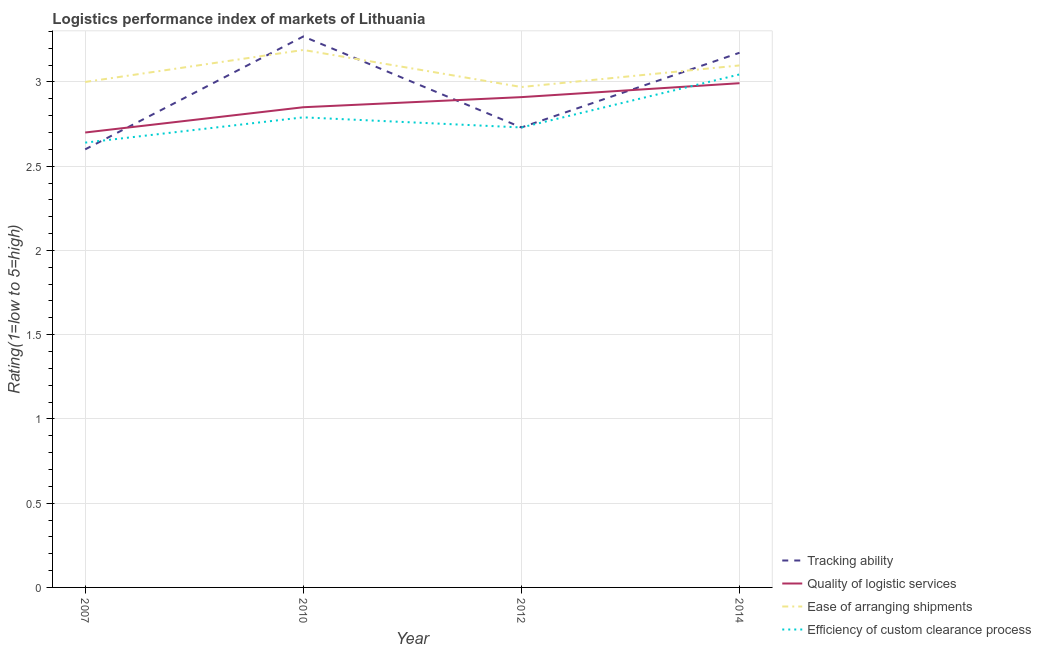What is the lpi rating of tracking ability in 2010?
Offer a very short reply. 3.27. Across all years, what is the maximum lpi rating of quality of logistic services?
Make the answer very short. 2.99. Across all years, what is the minimum lpi rating of ease of arranging shipments?
Provide a short and direct response. 2.97. In which year was the lpi rating of ease of arranging shipments maximum?
Make the answer very short. 2010. In which year was the lpi rating of efficiency of custom clearance process minimum?
Provide a short and direct response. 2007. What is the total lpi rating of efficiency of custom clearance process in the graph?
Your answer should be compact. 11.2. What is the difference between the lpi rating of ease of arranging shipments in 2012 and that in 2014?
Give a very brief answer. -0.13. What is the difference between the lpi rating of tracking ability in 2012 and the lpi rating of quality of logistic services in 2010?
Give a very brief answer. -0.12. What is the average lpi rating of efficiency of custom clearance process per year?
Keep it short and to the point. 2.8. In the year 2010, what is the difference between the lpi rating of quality of logistic services and lpi rating of tracking ability?
Offer a terse response. -0.42. In how many years, is the lpi rating of ease of arranging shipments greater than 1.5?
Your answer should be very brief. 4. What is the ratio of the lpi rating of efficiency of custom clearance process in 2007 to that in 2010?
Offer a very short reply. 0.95. What is the difference between the highest and the second highest lpi rating of efficiency of custom clearance process?
Your answer should be compact. 0.25. What is the difference between the highest and the lowest lpi rating of ease of arranging shipments?
Make the answer very short. 0.22. Is the sum of the lpi rating of ease of arranging shipments in 2007 and 2012 greater than the maximum lpi rating of tracking ability across all years?
Provide a succinct answer. Yes. What is the difference between two consecutive major ticks on the Y-axis?
Provide a succinct answer. 0.5. Does the graph contain any zero values?
Give a very brief answer. No. How many legend labels are there?
Provide a succinct answer. 4. What is the title of the graph?
Your response must be concise. Logistics performance index of markets of Lithuania. What is the label or title of the Y-axis?
Your answer should be very brief. Rating(1=low to 5=high). What is the Rating(1=low to 5=high) in Tracking ability in 2007?
Give a very brief answer. 2.6. What is the Rating(1=low to 5=high) of Quality of logistic services in 2007?
Provide a succinct answer. 2.7. What is the Rating(1=low to 5=high) of Ease of arranging shipments in 2007?
Offer a very short reply. 3. What is the Rating(1=low to 5=high) in Efficiency of custom clearance process in 2007?
Keep it short and to the point. 2.64. What is the Rating(1=low to 5=high) of Tracking ability in 2010?
Offer a terse response. 3.27. What is the Rating(1=low to 5=high) of Quality of logistic services in 2010?
Make the answer very short. 2.85. What is the Rating(1=low to 5=high) of Ease of arranging shipments in 2010?
Your answer should be compact. 3.19. What is the Rating(1=low to 5=high) of Efficiency of custom clearance process in 2010?
Your answer should be compact. 2.79. What is the Rating(1=low to 5=high) in Tracking ability in 2012?
Your answer should be compact. 2.73. What is the Rating(1=low to 5=high) of Quality of logistic services in 2012?
Offer a very short reply. 2.91. What is the Rating(1=low to 5=high) of Ease of arranging shipments in 2012?
Ensure brevity in your answer.  2.97. What is the Rating(1=low to 5=high) in Efficiency of custom clearance process in 2012?
Keep it short and to the point. 2.73. What is the Rating(1=low to 5=high) in Tracking ability in 2014?
Provide a short and direct response. 3.17. What is the Rating(1=low to 5=high) of Quality of logistic services in 2014?
Keep it short and to the point. 2.99. What is the Rating(1=low to 5=high) of Ease of arranging shipments in 2014?
Provide a succinct answer. 3.1. What is the Rating(1=low to 5=high) in Efficiency of custom clearance process in 2014?
Your answer should be very brief. 3.04. Across all years, what is the maximum Rating(1=low to 5=high) in Tracking ability?
Offer a terse response. 3.27. Across all years, what is the maximum Rating(1=low to 5=high) in Quality of logistic services?
Make the answer very short. 2.99. Across all years, what is the maximum Rating(1=low to 5=high) of Ease of arranging shipments?
Provide a succinct answer. 3.19. Across all years, what is the maximum Rating(1=low to 5=high) in Efficiency of custom clearance process?
Ensure brevity in your answer.  3.04. Across all years, what is the minimum Rating(1=low to 5=high) in Quality of logistic services?
Give a very brief answer. 2.7. Across all years, what is the minimum Rating(1=low to 5=high) of Ease of arranging shipments?
Provide a succinct answer. 2.97. Across all years, what is the minimum Rating(1=low to 5=high) in Efficiency of custom clearance process?
Your answer should be compact. 2.64. What is the total Rating(1=low to 5=high) in Tracking ability in the graph?
Offer a very short reply. 11.77. What is the total Rating(1=low to 5=high) in Quality of logistic services in the graph?
Offer a very short reply. 11.45. What is the total Rating(1=low to 5=high) of Ease of arranging shipments in the graph?
Your answer should be very brief. 12.26. What is the total Rating(1=low to 5=high) in Efficiency of custom clearance process in the graph?
Keep it short and to the point. 11.2. What is the difference between the Rating(1=low to 5=high) in Tracking ability in 2007 and that in 2010?
Make the answer very short. -0.67. What is the difference between the Rating(1=low to 5=high) of Quality of logistic services in 2007 and that in 2010?
Your answer should be compact. -0.15. What is the difference between the Rating(1=low to 5=high) of Ease of arranging shipments in 2007 and that in 2010?
Keep it short and to the point. -0.19. What is the difference between the Rating(1=low to 5=high) in Tracking ability in 2007 and that in 2012?
Give a very brief answer. -0.13. What is the difference between the Rating(1=low to 5=high) of Quality of logistic services in 2007 and that in 2012?
Offer a very short reply. -0.21. What is the difference between the Rating(1=low to 5=high) in Ease of arranging shipments in 2007 and that in 2012?
Provide a succinct answer. 0.03. What is the difference between the Rating(1=low to 5=high) of Efficiency of custom clearance process in 2007 and that in 2012?
Offer a very short reply. -0.09. What is the difference between the Rating(1=low to 5=high) in Tracking ability in 2007 and that in 2014?
Your answer should be very brief. -0.57. What is the difference between the Rating(1=low to 5=high) of Quality of logistic services in 2007 and that in 2014?
Your response must be concise. -0.29. What is the difference between the Rating(1=low to 5=high) in Ease of arranging shipments in 2007 and that in 2014?
Ensure brevity in your answer.  -0.1. What is the difference between the Rating(1=low to 5=high) in Efficiency of custom clearance process in 2007 and that in 2014?
Make the answer very short. -0.4. What is the difference between the Rating(1=low to 5=high) of Tracking ability in 2010 and that in 2012?
Make the answer very short. 0.54. What is the difference between the Rating(1=low to 5=high) in Quality of logistic services in 2010 and that in 2012?
Ensure brevity in your answer.  -0.06. What is the difference between the Rating(1=low to 5=high) of Ease of arranging shipments in 2010 and that in 2012?
Provide a succinct answer. 0.22. What is the difference between the Rating(1=low to 5=high) of Efficiency of custom clearance process in 2010 and that in 2012?
Your response must be concise. 0.06. What is the difference between the Rating(1=low to 5=high) of Tracking ability in 2010 and that in 2014?
Your response must be concise. 0.1. What is the difference between the Rating(1=low to 5=high) of Quality of logistic services in 2010 and that in 2014?
Provide a short and direct response. -0.14. What is the difference between the Rating(1=low to 5=high) in Ease of arranging shipments in 2010 and that in 2014?
Offer a very short reply. 0.09. What is the difference between the Rating(1=low to 5=high) of Efficiency of custom clearance process in 2010 and that in 2014?
Ensure brevity in your answer.  -0.25. What is the difference between the Rating(1=low to 5=high) in Tracking ability in 2012 and that in 2014?
Provide a succinct answer. -0.44. What is the difference between the Rating(1=low to 5=high) in Quality of logistic services in 2012 and that in 2014?
Give a very brief answer. -0.08. What is the difference between the Rating(1=low to 5=high) of Ease of arranging shipments in 2012 and that in 2014?
Your answer should be compact. -0.13. What is the difference between the Rating(1=low to 5=high) in Efficiency of custom clearance process in 2012 and that in 2014?
Ensure brevity in your answer.  -0.31. What is the difference between the Rating(1=low to 5=high) of Tracking ability in 2007 and the Rating(1=low to 5=high) of Ease of arranging shipments in 2010?
Offer a very short reply. -0.59. What is the difference between the Rating(1=low to 5=high) of Tracking ability in 2007 and the Rating(1=low to 5=high) of Efficiency of custom clearance process in 2010?
Provide a succinct answer. -0.19. What is the difference between the Rating(1=low to 5=high) in Quality of logistic services in 2007 and the Rating(1=low to 5=high) in Ease of arranging shipments in 2010?
Keep it short and to the point. -0.49. What is the difference between the Rating(1=low to 5=high) of Quality of logistic services in 2007 and the Rating(1=low to 5=high) of Efficiency of custom clearance process in 2010?
Your response must be concise. -0.09. What is the difference between the Rating(1=low to 5=high) of Ease of arranging shipments in 2007 and the Rating(1=low to 5=high) of Efficiency of custom clearance process in 2010?
Make the answer very short. 0.21. What is the difference between the Rating(1=low to 5=high) of Tracking ability in 2007 and the Rating(1=low to 5=high) of Quality of logistic services in 2012?
Provide a short and direct response. -0.31. What is the difference between the Rating(1=low to 5=high) of Tracking ability in 2007 and the Rating(1=low to 5=high) of Ease of arranging shipments in 2012?
Keep it short and to the point. -0.37. What is the difference between the Rating(1=low to 5=high) in Tracking ability in 2007 and the Rating(1=low to 5=high) in Efficiency of custom clearance process in 2012?
Your answer should be very brief. -0.13. What is the difference between the Rating(1=low to 5=high) in Quality of logistic services in 2007 and the Rating(1=low to 5=high) in Ease of arranging shipments in 2012?
Offer a very short reply. -0.27. What is the difference between the Rating(1=low to 5=high) of Quality of logistic services in 2007 and the Rating(1=low to 5=high) of Efficiency of custom clearance process in 2012?
Give a very brief answer. -0.03. What is the difference between the Rating(1=low to 5=high) of Ease of arranging shipments in 2007 and the Rating(1=low to 5=high) of Efficiency of custom clearance process in 2012?
Offer a very short reply. 0.27. What is the difference between the Rating(1=low to 5=high) of Tracking ability in 2007 and the Rating(1=low to 5=high) of Quality of logistic services in 2014?
Give a very brief answer. -0.39. What is the difference between the Rating(1=low to 5=high) in Tracking ability in 2007 and the Rating(1=low to 5=high) in Ease of arranging shipments in 2014?
Your answer should be compact. -0.5. What is the difference between the Rating(1=low to 5=high) in Tracking ability in 2007 and the Rating(1=low to 5=high) in Efficiency of custom clearance process in 2014?
Ensure brevity in your answer.  -0.44. What is the difference between the Rating(1=low to 5=high) in Quality of logistic services in 2007 and the Rating(1=low to 5=high) in Ease of arranging shipments in 2014?
Offer a terse response. -0.4. What is the difference between the Rating(1=low to 5=high) of Quality of logistic services in 2007 and the Rating(1=low to 5=high) of Efficiency of custom clearance process in 2014?
Provide a succinct answer. -0.34. What is the difference between the Rating(1=low to 5=high) in Ease of arranging shipments in 2007 and the Rating(1=low to 5=high) in Efficiency of custom clearance process in 2014?
Your response must be concise. -0.04. What is the difference between the Rating(1=low to 5=high) in Tracking ability in 2010 and the Rating(1=low to 5=high) in Quality of logistic services in 2012?
Offer a terse response. 0.36. What is the difference between the Rating(1=low to 5=high) of Tracking ability in 2010 and the Rating(1=low to 5=high) of Ease of arranging shipments in 2012?
Provide a short and direct response. 0.3. What is the difference between the Rating(1=low to 5=high) in Tracking ability in 2010 and the Rating(1=low to 5=high) in Efficiency of custom clearance process in 2012?
Give a very brief answer. 0.54. What is the difference between the Rating(1=low to 5=high) in Quality of logistic services in 2010 and the Rating(1=low to 5=high) in Ease of arranging shipments in 2012?
Give a very brief answer. -0.12. What is the difference between the Rating(1=low to 5=high) in Quality of logistic services in 2010 and the Rating(1=low to 5=high) in Efficiency of custom clearance process in 2012?
Provide a succinct answer. 0.12. What is the difference between the Rating(1=low to 5=high) in Ease of arranging shipments in 2010 and the Rating(1=low to 5=high) in Efficiency of custom clearance process in 2012?
Offer a very short reply. 0.46. What is the difference between the Rating(1=low to 5=high) of Tracking ability in 2010 and the Rating(1=low to 5=high) of Quality of logistic services in 2014?
Keep it short and to the point. 0.28. What is the difference between the Rating(1=low to 5=high) of Tracking ability in 2010 and the Rating(1=low to 5=high) of Ease of arranging shipments in 2014?
Provide a succinct answer. 0.17. What is the difference between the Rating(1=low to 5=high) in Tracking ability in 2010 and the Rating(1=low to 5=high) in Efficiency of custom clearance process in 2014?
Offer a very short reply. 0.23. What is the difference between the Rating(1=low to 5=high) of Quality of logistic services in 2010 and the Rating(1=low to 5=high) of Ease of arranging shipments in 2014?
Keep it short and to the point. -0.25. What is the difference between the Rating(1=low to 5=high) of Quality of logistic services in 2010 and the Rating(1=low to 5=high) of Efficiency of custom clearance process in 2014?
Ensure brevity in your answer.  -0.19. What is the difference between the Rating(1=low to 5=high) of Ease of arranging shipments in 2010 and the Rating(1=low to 5=high) of Efficiency of custom clearance process in 2014?
Your response must be concise. 0.15. What is the difference between the Rating(1=low to 5=high) of Tracking ability in 2012 and the Rating(1=low to 5=high) of Quality of logistic services in 2014?
Your answer should be compact. -0.26. What is the difference between the Rating(1=low to 5=high) in Tracking ability in 2012 and the Rating(1=low to 5=high) in Ease of arranging shipments in 2014?
Make the answer very short. -0.37. What is the difference between the Rating(1=low to 5=high) in Tracking ability in 2012 and the Rating(1=low to 5=high) in Efficiency of custom clearance process in 2014?
Your response must be concise. -0.31. What is the difference between the Rating(1=low to 5=high) of Quality of logistic services in 2012 and the Rating(1=low to 5=high) of Ease of arranging shipments in 2014?
Give a very brief answer. -0.19. What is the difference between the Rating(1=low to 5=high) of Quality of logistic services in 2012 and the Rating(1=low to 5=high) of Efficiency of custom clearance process in 2014?
Offer a very short reply. -0.13. What is the difference between the Rating(1=low to 5=high) in Ease of arranging shipments in 2012 and the Rating(1=low to 5=high) in Efficiency of custom clearance process in 2014?
Provide a short and direct response. -0.07. What is the average Rating(1=low to 5=high) in Tracking ability per year?
Your answer should be very brief. 2.94. What is the average Rating(1=low to 5=high) of Quality of logistic services per year?
Your answer should be very brief. 2.86. What is the average Rating(1=low to 5=high) of Ease of arranging shipments per year?
Ensure brevity in your answer.  3.06. What is the average Rating(1=low to 5=high) of Efficiency of custom clearance process per year?
Make the answer very short. 2.8. In the year 2007, what is the difference between the Rating(1=low to 5=high) in Tracking ability and Rating(1=low to 5=high) in Efficiency of custom clearance process?
Provide a succinct answer. -0.04. In the year 2007, what is the difference between the Rating(1=low to 5=high) of Ease of arranging shipments and Rating(1=low to 5=high) of Efficiency of custom clearance process?
Keep it short and to the point. 0.36. In the year 2010, what is the difference between the Rating(1=low to 5=high) in Tracking ability and Rating(1=low to 5=high) in Quality of logistic services?
Your answer should be very brief. 0.42. In the year 2010, what is the difference between the Rating(1=low to 5=high) in Tracking ability and Rating(1=low to 5=high) in Efficiency of custom clearance process?
Provide a succinct answer. 0.48. In the year 2010, what is the difference between the Rating(1=low to 5=high) of Quality of logistic services and Rating(1=low to 5=high) of Ease of arranging shipments?
Your response must be concise. -0.34. In the year 2010, what is the difference between the Rating(1=low to 5=high) in Ease of arranging shipments and Rating(1=low to 5=high) in Efficiency of custom clearance process?
Keep it short and to the point. 0.4. In the year 2012, what is the difference between the Rating(1=low to 5=high) in Tracking ability and Rating(1=low to 5=high) in Quality of logistic services?
Make the answer very short. -0.18. In the year 2012, what is the difference between the Rating(1=low to 5=high) of Tracking ability and Rating(1=low to 5=high) of Ease of arranging shipments?
Keep it short and to the point. -0.24. In the year 2012, what is the difference between the Rating(1=low to 5=high) of Tracking ability and Rating(1=low to 5=high) of Efficiency of custom clearance process?
Offer a terse response. 0. In the year 2012, what is the difference between the Rating(1=low to 5=high) of Quality of logistic services and Rating(1=low to 5=high) of Ease of arranging shipments?
Give a very brief answer. -0.06. In the year 2012, what is the difference between the Rating(1=low to 5=high) of Quality of logistic services and Rating(1=low to 5=high) of Efficiency of custom clearance process?
Make the answer very short. 0.18. In the year 2012, what is the difference between the Rating(1=low to 5=high) in Ease of arranging shipments and Rating(1=low to 5=high) in Efficiency of custom clearance process?
Your response must be concise. 0.24. In the year 2014, what is the difference between the Rating(1=low to 5=high) of Tracking ability and Rating(1=low to 5=high) of Quality of logistic services?
Your answer should be compact. 0.18. In the year 2014, what is the difference between the Rating(1=low to 5=high) in Tracking ability and Rating(1=low to 5=high) in Ease of arranging shipments?
Offer a terse response. 0.08. In the year 2014, what is the difference between the Rating(1=low to 5=high) in Tracking ability and Rating(1=low to 5=high) in Efficiency of custom clearance process?
Make the answer very short. 0.13. In the year 2014, what is the difference between the Rating(1=low to 5=high) of Quality of logistic services and Rating(1=low to 5=high) of Ease of arranging shipments?
Provide a short and direct response. -0.11. In the year 2014, what is the difference between the Rating(1=low to 5=high) in Quality of logistic services and Rating(1=low to 5=high) in Efficiency of custom clearance process?
Provide a short and direct response. -0.05. In the year 2014, what is the difference between the Rating(1=low to 5=high) of Ease of arranging shipments and Rating(1=low to 5=high) of Efficiency of custom clearance process?
Give a very brief answer. 0.05. What is the ratio of the Rating(1=low to 5=high) of Tracking ability in 2007 to that in 2010?
Keep it short and to the point. 0.8. What is the ratio of the Rating(1=low to 5=high) in Quality of logistic services in 2007 to that in 2010?
Your answer should be very brief. 0.95. What is the ratio of the Rating(1=low to 5=high) in Ease of arranging shipments in 2007 to that in 2010?
Provide a succinct answer. 0.94. What is the ratio of the Rating(1=low to 5=high) in Efficiency of custom clearance process in 2007 to that in 2010?
Offer a terse response. 0.95. What is the ratio of the Rating(1=low to 5=high) of Tracking ability in 2007 to that in 2012?
Provide a short and direct response. 0.95. What is the ratio of the Rating(1=low to 5=high) of Quality of logistic services in 2007 to that in 2012?
Your response must be concise. 0.93. What is the ratio of the Rating(1=low to 5=high) of Tracking ability in 2007 to that in 2014?
Offer a very short reply. 0.82. What is the ratio of the Rating(1=low to 5=high) in Quality of logistic services in 2007 to that in 2014?
Make the answer very short. 0.9. What is the ratio of the Rating(1=low to 5=high) of Ease of arranging shipments in 2007 to that in 2014?
Keep it short and to the point. 0.97. What is the ratio of the Rating(1=low to 5=high) of Efficiency of custom clearance process in 2007 to that in 2014?
Provide a succinct answer. 0.87. What is the ratio of the Rating(1=low to 5=high) in Tracking ability in 2010 to that in 2012?
Ensure brevity in your answer.  1.2. What is the ratio of the Rating(1=low to 5=high) of Quality of logistic services in 2010 to that in 2012?
Your answer should be very brief. 0.98. What is the ratio of the Rating(1=low to 5=high) of Ease of arranging shipments in 2010 to that in 2012?
Make the answer very short. 1.07. What is the ratio of the Rating(1=low to 5=high) of Tracking ability in 2010 to that in 2014?
Your response must be concise. 1.03. What is the ratio of the Rating(1=low to 5=high) in Quality of logistic services in 2010 to that in 2014?
Provide a succinct answer. 0.95. What is the ratio of the Rating(1=low to 5=high) of Ease of arranging shipments in 2010 to that in 2014?
Provide a succinct answer. 1.03. What is the ratio of the Rating(1=low to 5=high) in Efficiency of custom clearance process in 2010 to that in 2014?
Ensure brevity in your answer.  0.92. What is the ratio of the Rating(1=low to 5=high) in Tracking ability in 2012 to that in 2014?
Provide a short and direct response. 0.86. What is the ratio of the Rating(1=low to 5=high) of Quality of logistic services in 2012 to that in 2014?
Ensure brevity in your answer.  0.97. What is the ratio of the Rating(1=low to 5=high) in Ease of arranging shipments in 2012 to that in 2014?
Your response must be concise. 0.96. What is the ratio of the Rating(1=low to 5=high) of Efficiency of custom clearance process in 2012 to that in 2014?
Keep it short and to the point. 0.9. What is the difference between the highest and the second highest Rating(1=low to 5=high) of Tracking ability?
Ensure brevity in your answer.  0.1. What is the difference between the highest and the second highest Rating(1=low to 5=high) in Quality of logistic services?
Give a very brief answer. 0.08. What is the difference between the highest and the second highest Rating(1=low to 5=high) in Ease of arranging shipments?
Ensure brevity in your answer.  0.09. What is the difference between the highest and the second highest Rating(1=low to 5=high) of Efficiency of custom clearance process?
Ensure brevity in your answer.  0.25. What is the difference between the highest and the lowest Rating(1=low to 5=high) in Tracking ability?
Your answer should be very brief. 0.67. What is the difference between the highest and the lowest Rating(1=low to 5=high) of Quality of logistic services?
Ensure brevity in your answer.  0.29. What is the difference between the highest and the lowest Rating(1=low to 5=high) of Ease of arranging shipments?
Your response must be concise. 0.22. What is the difference between the highest and the lowest Rating(1=low to 5=high) of Efficiency of custom clearance process?
Keep it short and to the point. 0.4. 